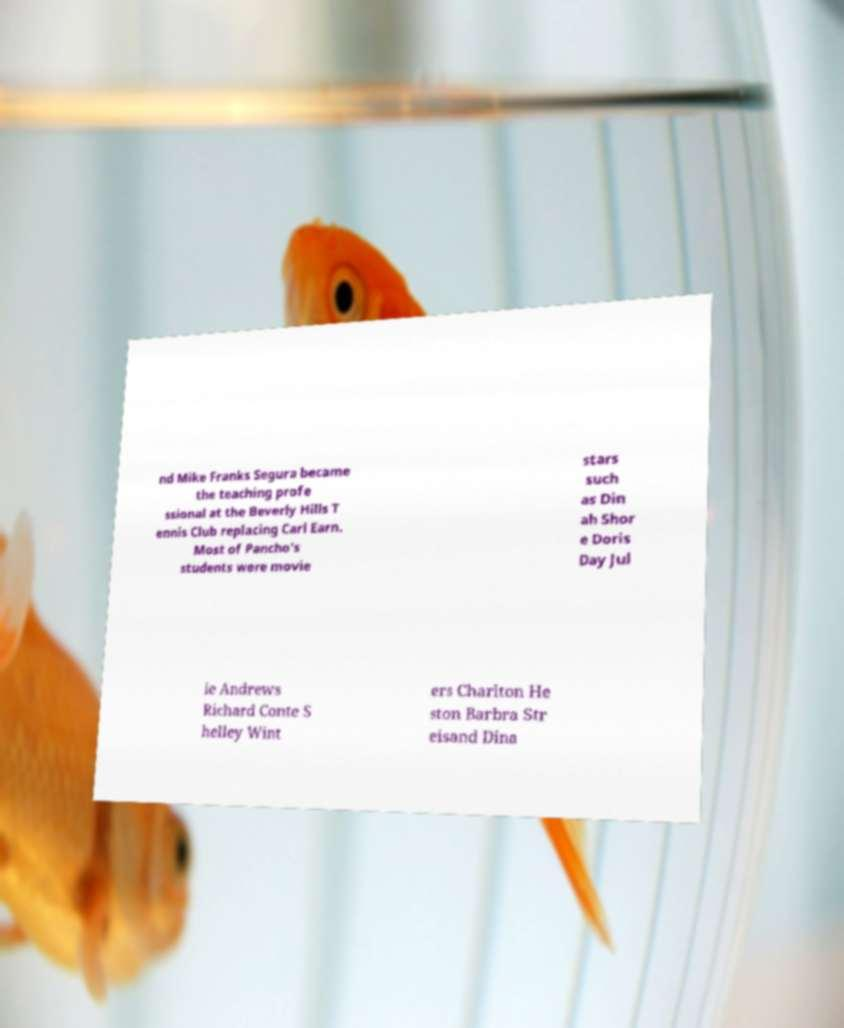There's text embedded in this image that I need extracted. Can you transcribe it verbatim? nd Mike Franks Segura became the teaching profe ssional at the Beverly Hills T ennis Club replacing Carl Earn. Most of Pancho's students were movie stars such as Din ah Shor e Doris Day Jul ie Andrews Richard Conte S helley Wint ers Charlton He ston Barbra Str eisand Dina 